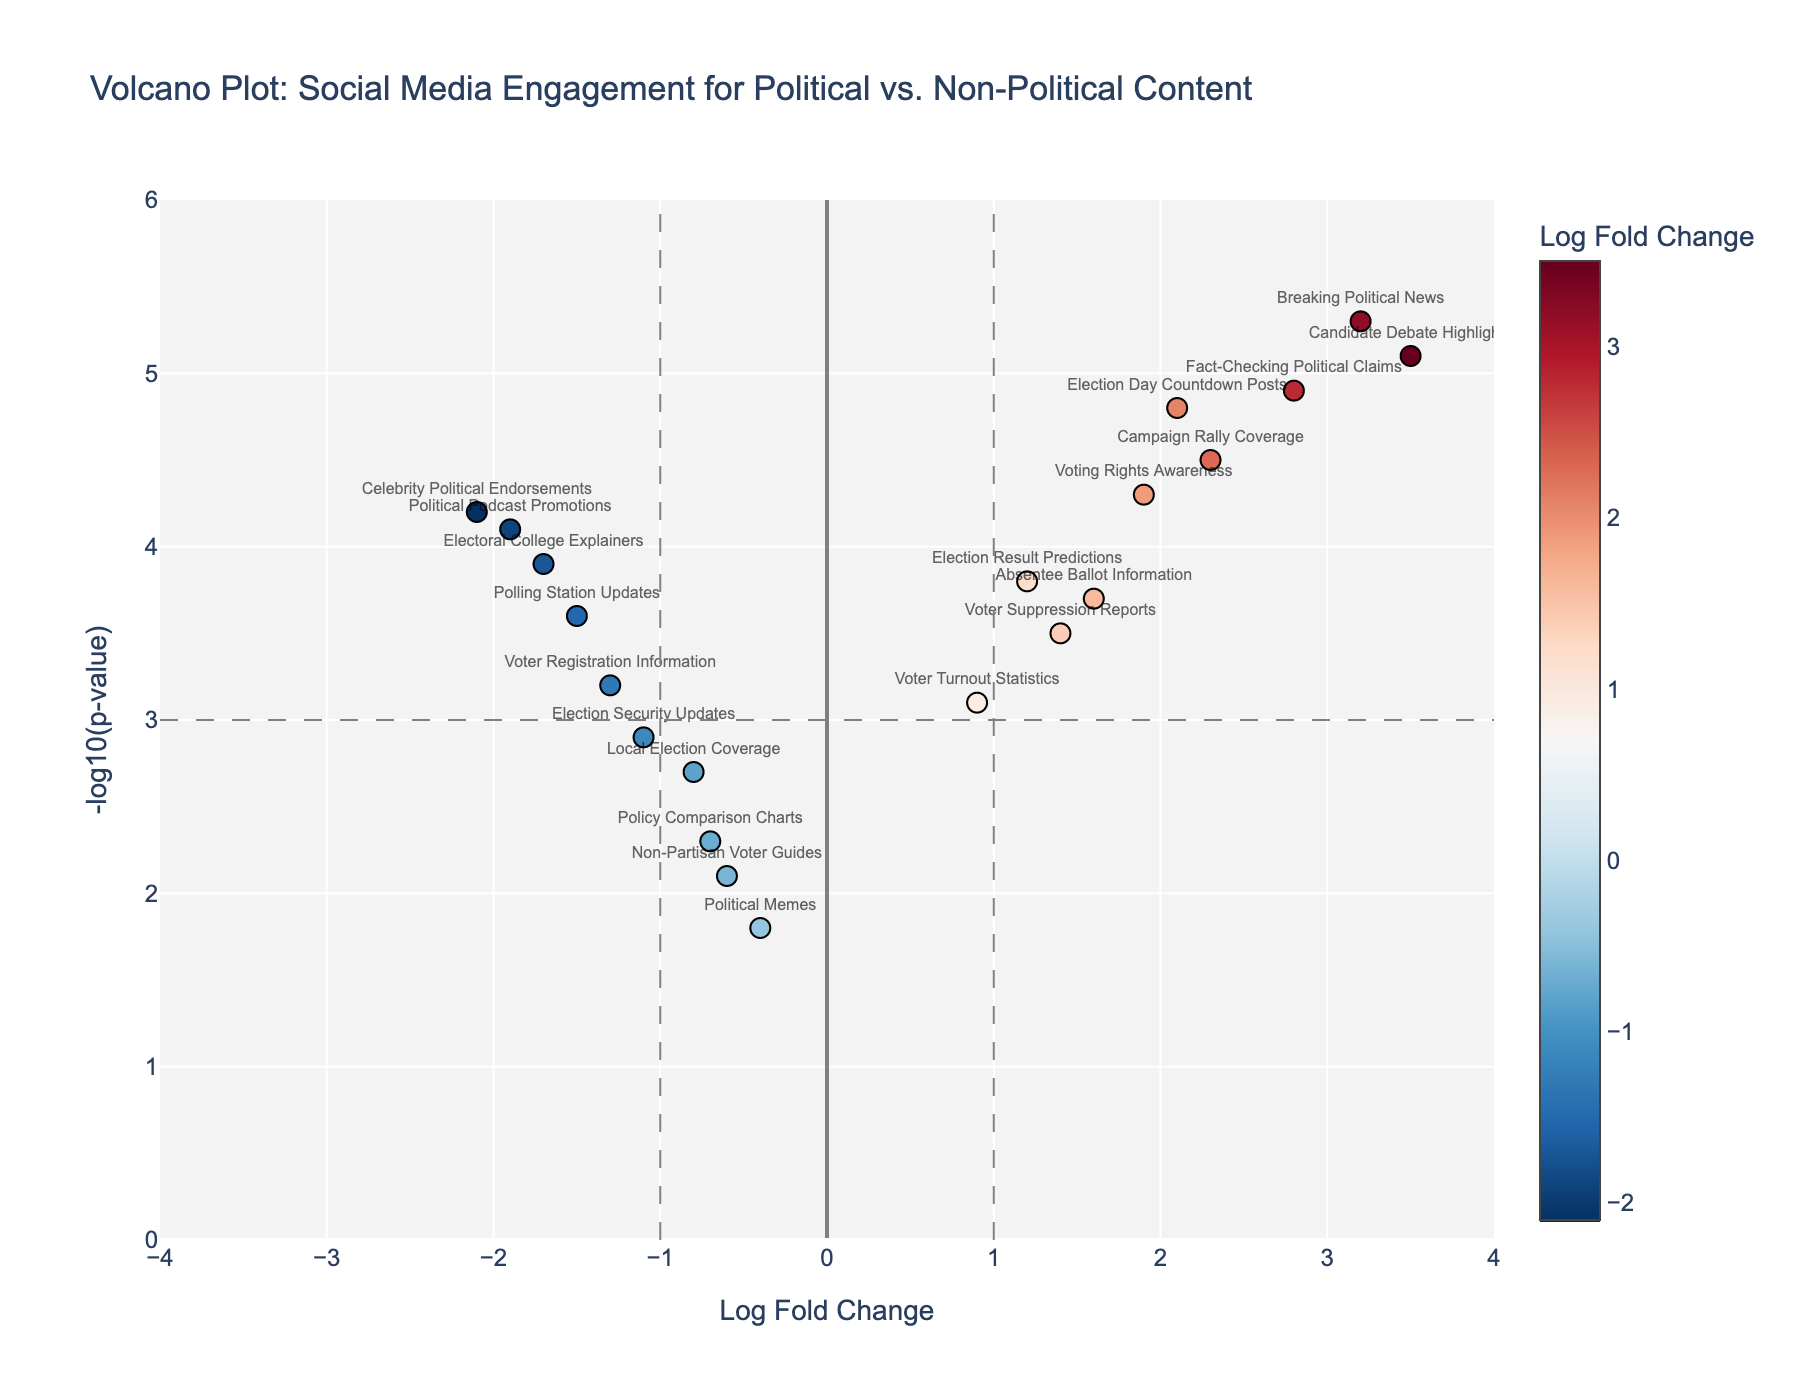How many types of social media posts are analyzed in the plot? Count the number of unique data points (markers) on the plot.
Answer: 20 What is the title of the plot? Refer to the top of the plot to read the title.
Answer: Volcano Plot: Social Media Engagement for Political vs. Non-Political Content Which type of content has the highest negative log p-value? Identify the highest y-axis value and check the corresponding content.
Answer: Breaking Political News What is the log fold change value of 'Voter Turnout Statistics'? Locate the text label for 'Voter Turnout Statistics' and read the x-axis value.
Answer: 0.9 How many posts have a log fold change greater than 2? Count the number of points to the right of the x = 2 line.
Answer: 5 How many posts have a negative log p-value less than 3? Count the number of points below the horizontal y = 3 line.
Answer: 8 Which type of content has the most significant negative log fold change value? Identify the lowest x-axis value and check the corresponding content.
Answer: Celebrity Political Endorsements Compare the negative log p-values of 'Polling Station Updates' and 'Election Security Updates'. Which one is higher? Locate the y-axis values for both and compare them.
Answer: Polling Station Updates Identify a type of content that has a log fold change close to zero but a significant negative log p-value. Look for points near x = 0 with high y values.
Answer: Non-Partisan Voter Guides Is there more political content with positive log fold changes or negative log fold changes? Count the points on either side of the vertical line at x = 0.
Answer: Positive log fold changes 